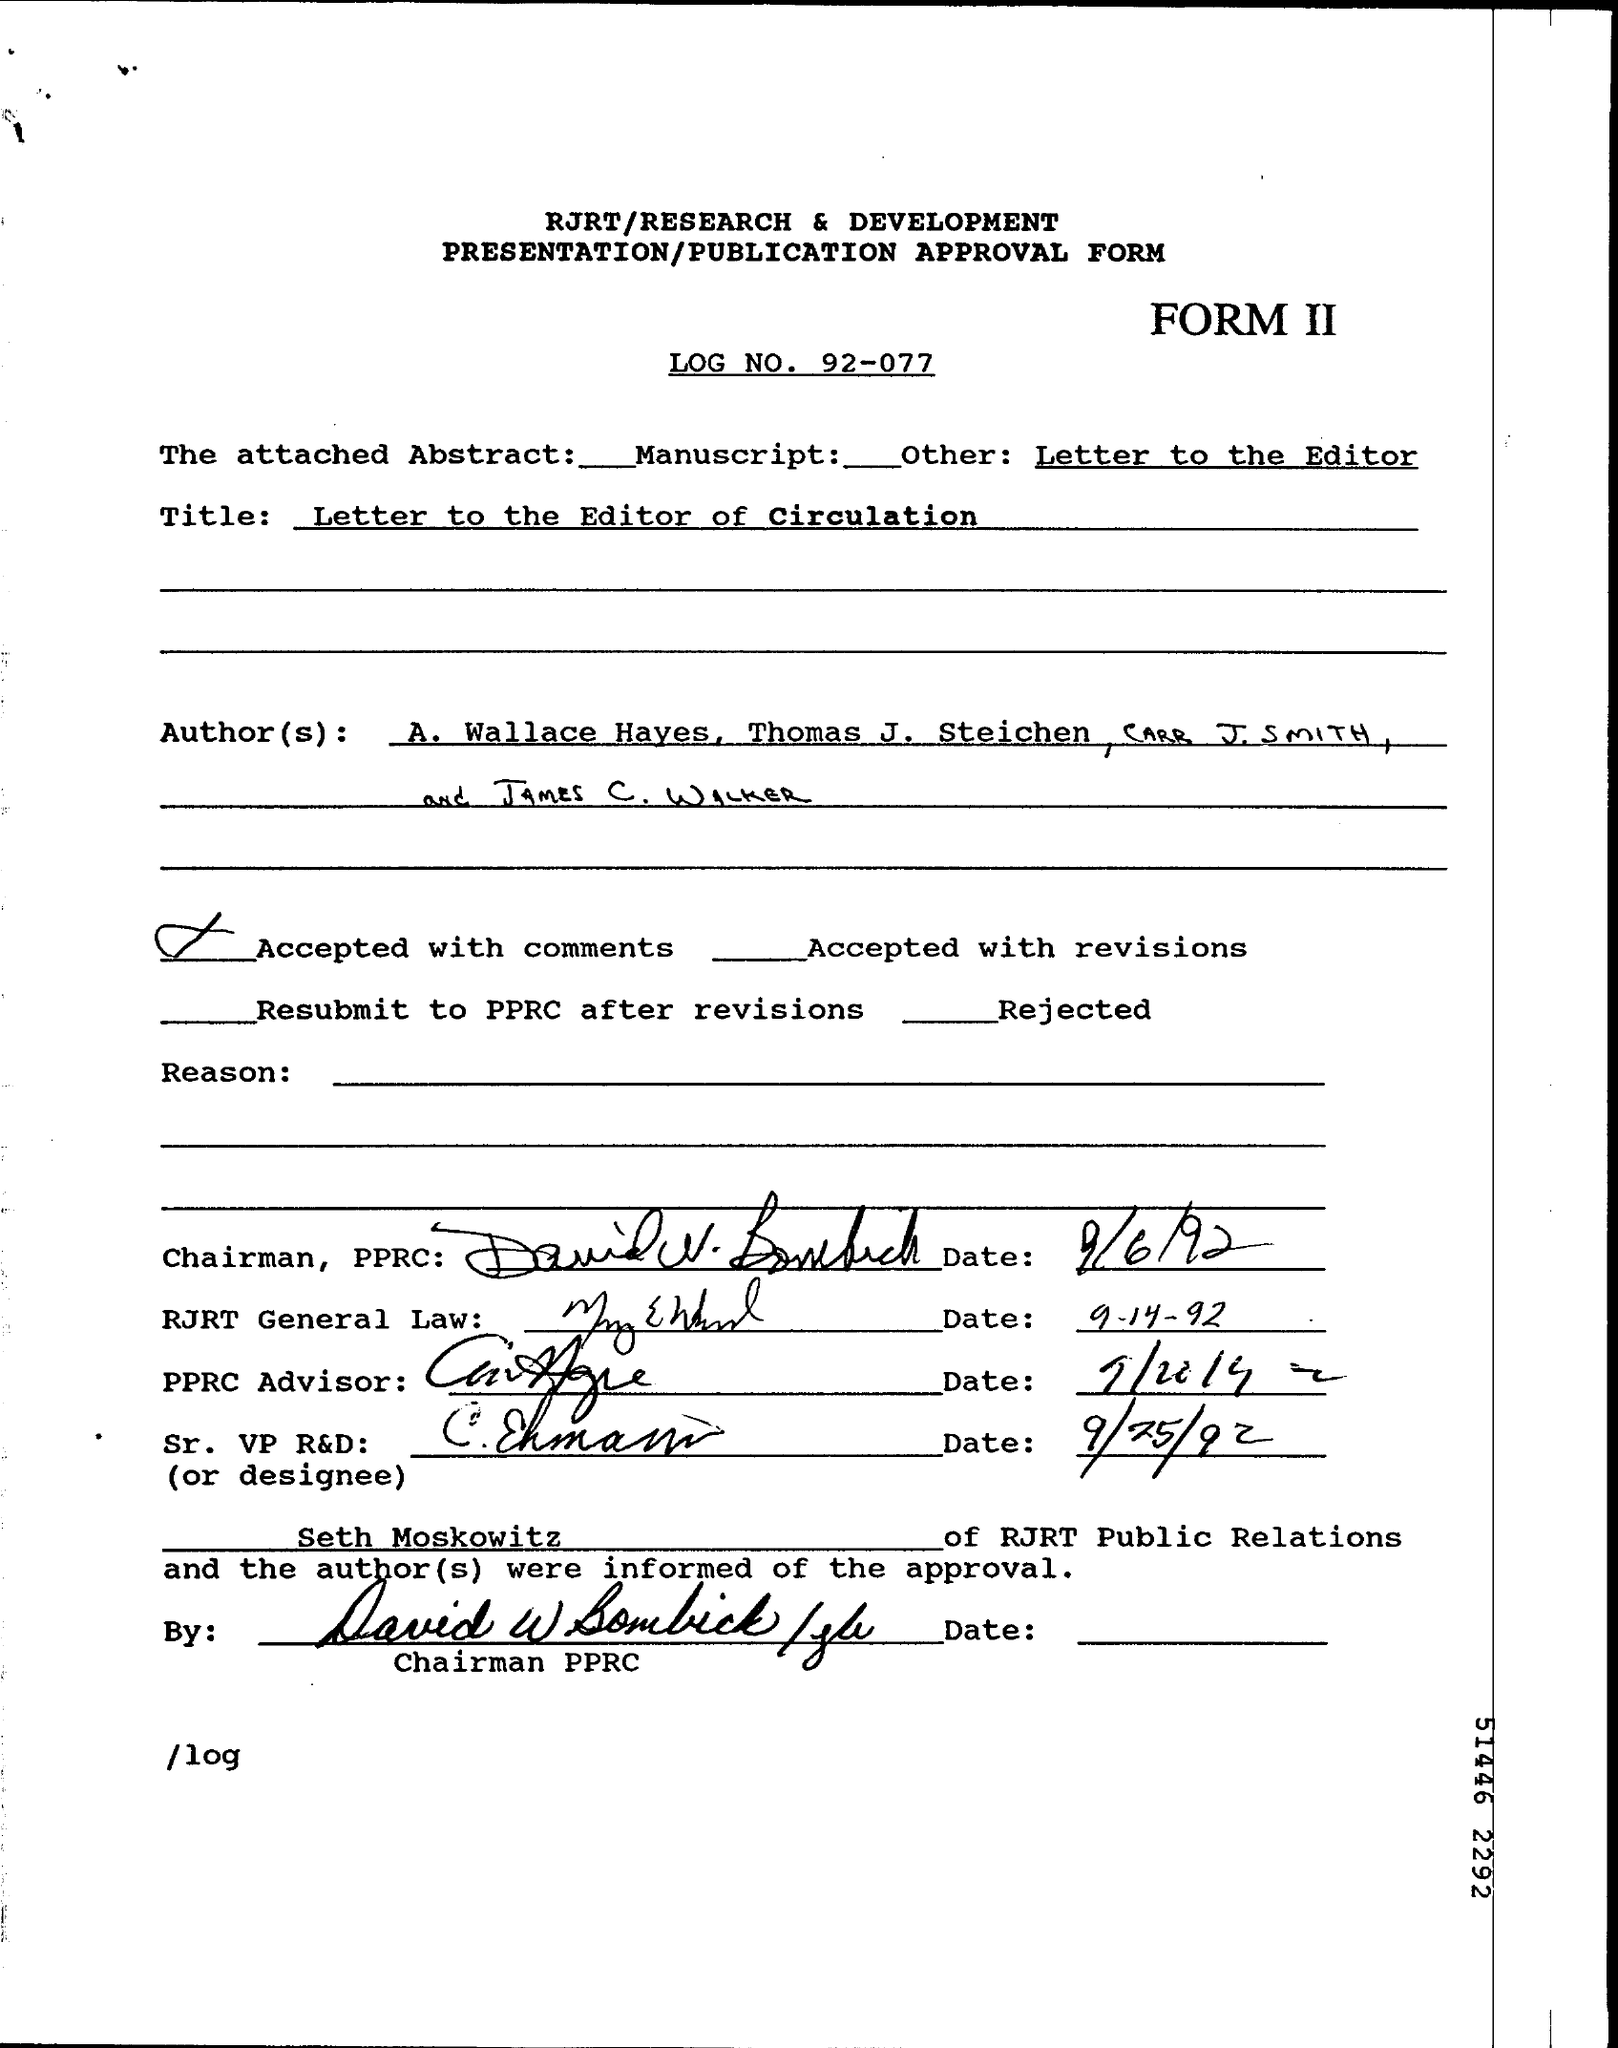Point out several critical features in this image. The attached abstract refers to a manuscript. What is mentioned as "Title" refers to a letter to the editor of circulation. The date of the signature of the Chairman is September 6, 1992. 